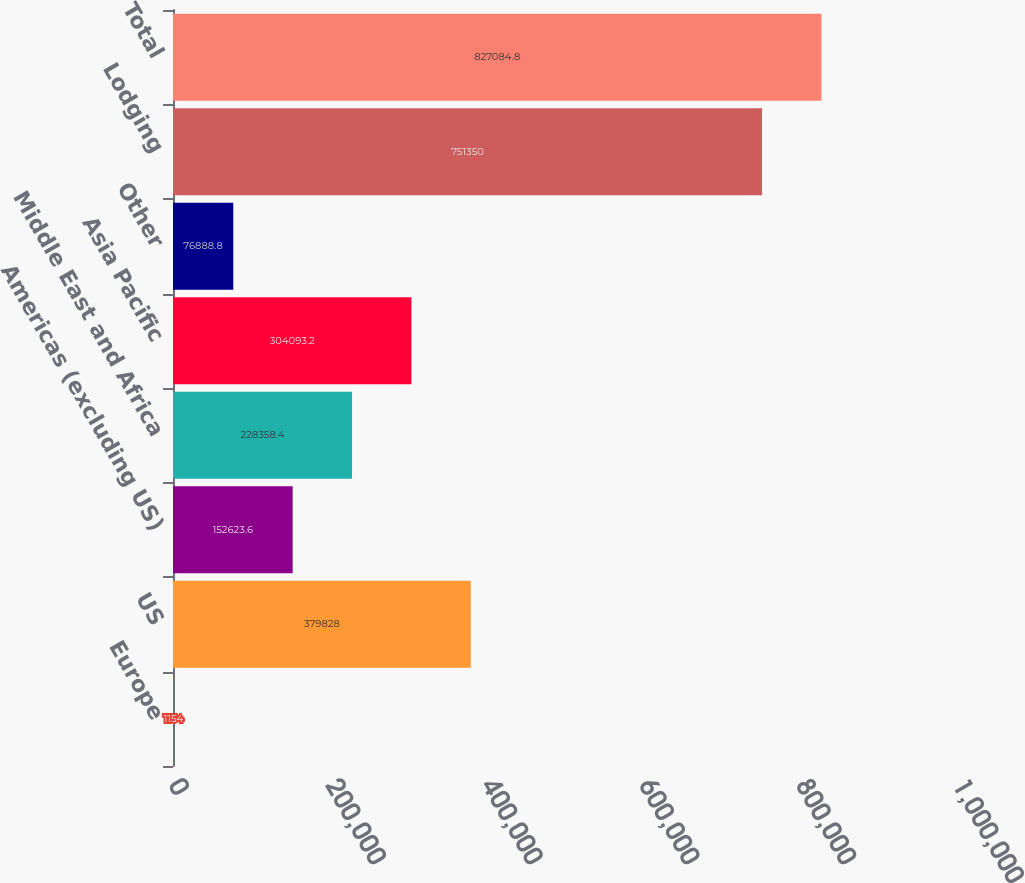<chart> <loc_0><loc_0><loc_500><loc_500><bar_chart><fcel>Europe<fcel>US<fcel>Americas (excluding US)<fcel>Middle East and Africa<fcel>Asia Pacific<fcel>Other<fcel>Lodging<fcel>Total<nl><fcel>1154<fcel>379828<fcel>152624<fcel>228358<fcel>304093<fcel>76888.8<fcel>751350<fcel>827085<nl></chart> 